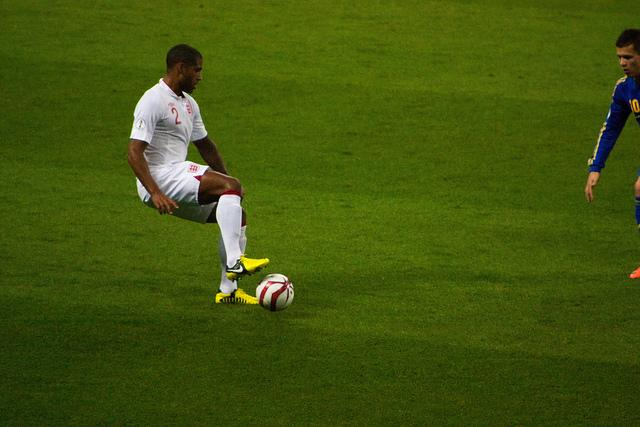The man with the ball has shoes that have a majority color that matches the color of what?

Choices:
A) horse
B) cow's tongue
C) mallard's bill
D) zebra mallard's bill 